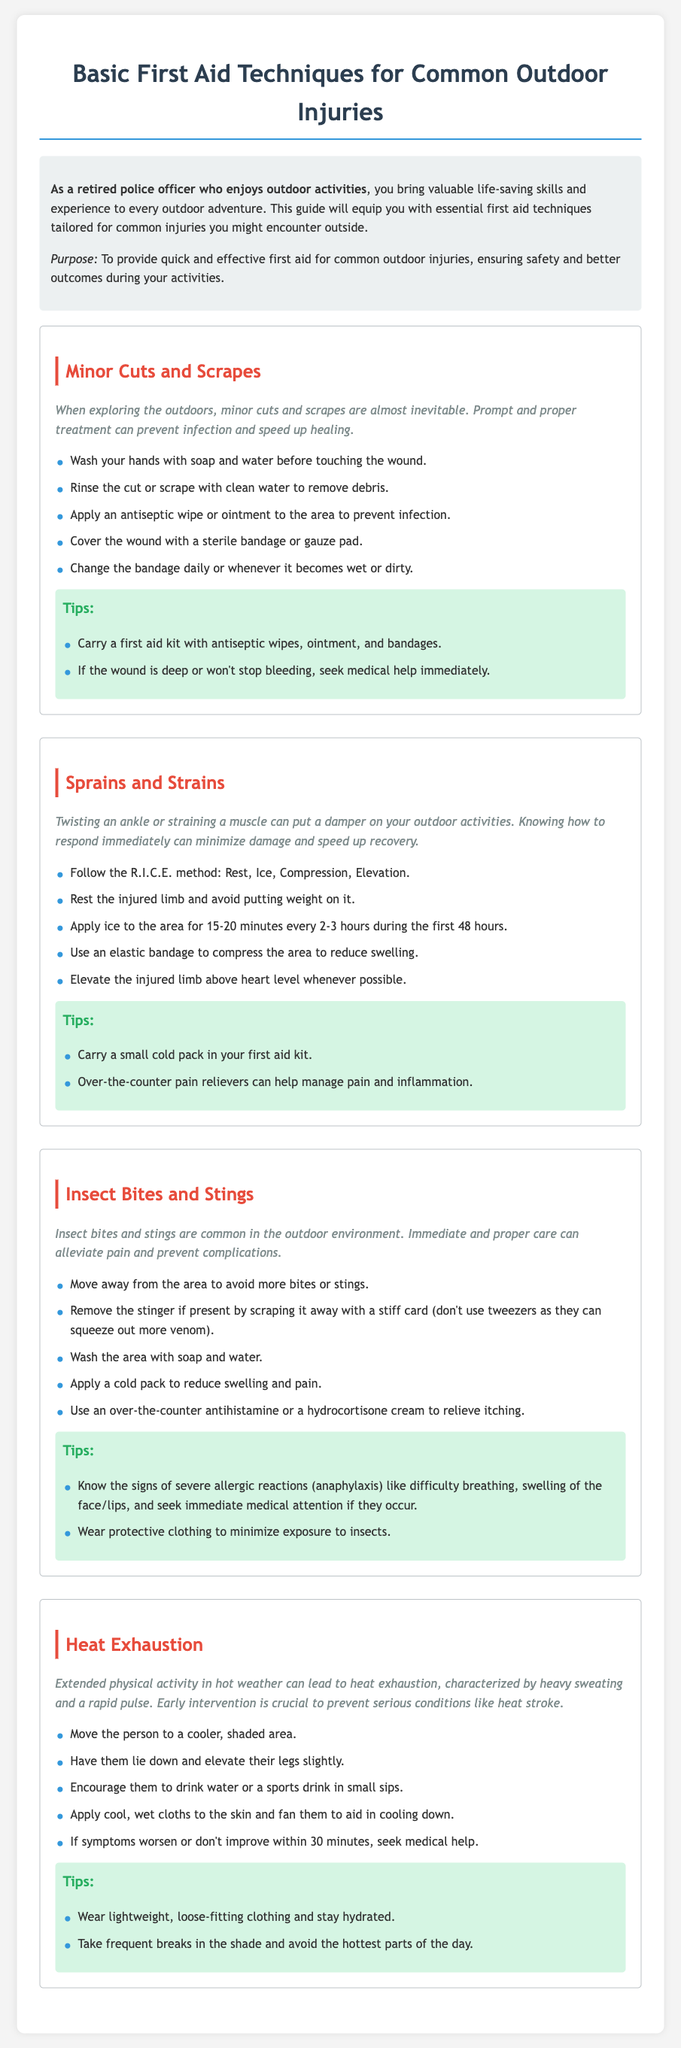What is the purpose of the guide? The guide aims to provide quick and effective first aid for common outdoor injuries, ensuring safety and better outcomes during activities.
Answer: To provide quick and effective first aid for common outdoor injuries What does R.I.C.E. stand for? R.I.C.E. is an acronym for Rest, Ice, Compression, and Elevation, which are the steps to treat sprains and strains.
Answer: Rest, Ice, Compression, Elevation What type of injuries does the guide focus on? The guide focuses on common outdoor injuries, which include minor cuts, sprains, insect bites, and heat exhaustion.
Answer: Common outdoor injuries How long should ice be applied to a sprain? The guide recommends applying ice to the injured area for 15-20 minutes every 2-3 hours during the first 48 hours.
Answer: 15-20 minutes What should you do if symptoms worsen after treatment for heat exhaustion? If symptoms worsen or don't improve within 30 minutes after treatment, medical help should be sought.
Answer: Seek medical help What type of clothing is recommended to prevent heat exhaustion? The guide suggests wearing lightweight, loose-fitting clothing to help prevent heat exhaustion.
Answer: Lightweight, loose-fitting clothing What is advised for insect bites if a stinger is present? The guide advises to remove the stinger by scraping it away with a stiff card rather than using tweezers.
Answer: Scrape it away with a stiff card What should you carry in your first aid kit for insect bites? The guide recommends having over-the-counter antihistamines or hydrocortisone cream for treating insect bites.
Answer: Antihistamine or hydrocortisone cream How can you tell if an insect bite is severe? The guide lists signs of severe allergic reactions, such as difficulty breathing and swelling of the face or lips, that require immediate medical attention.
Answer: Difficulty breathing, swelling of the face/lips 